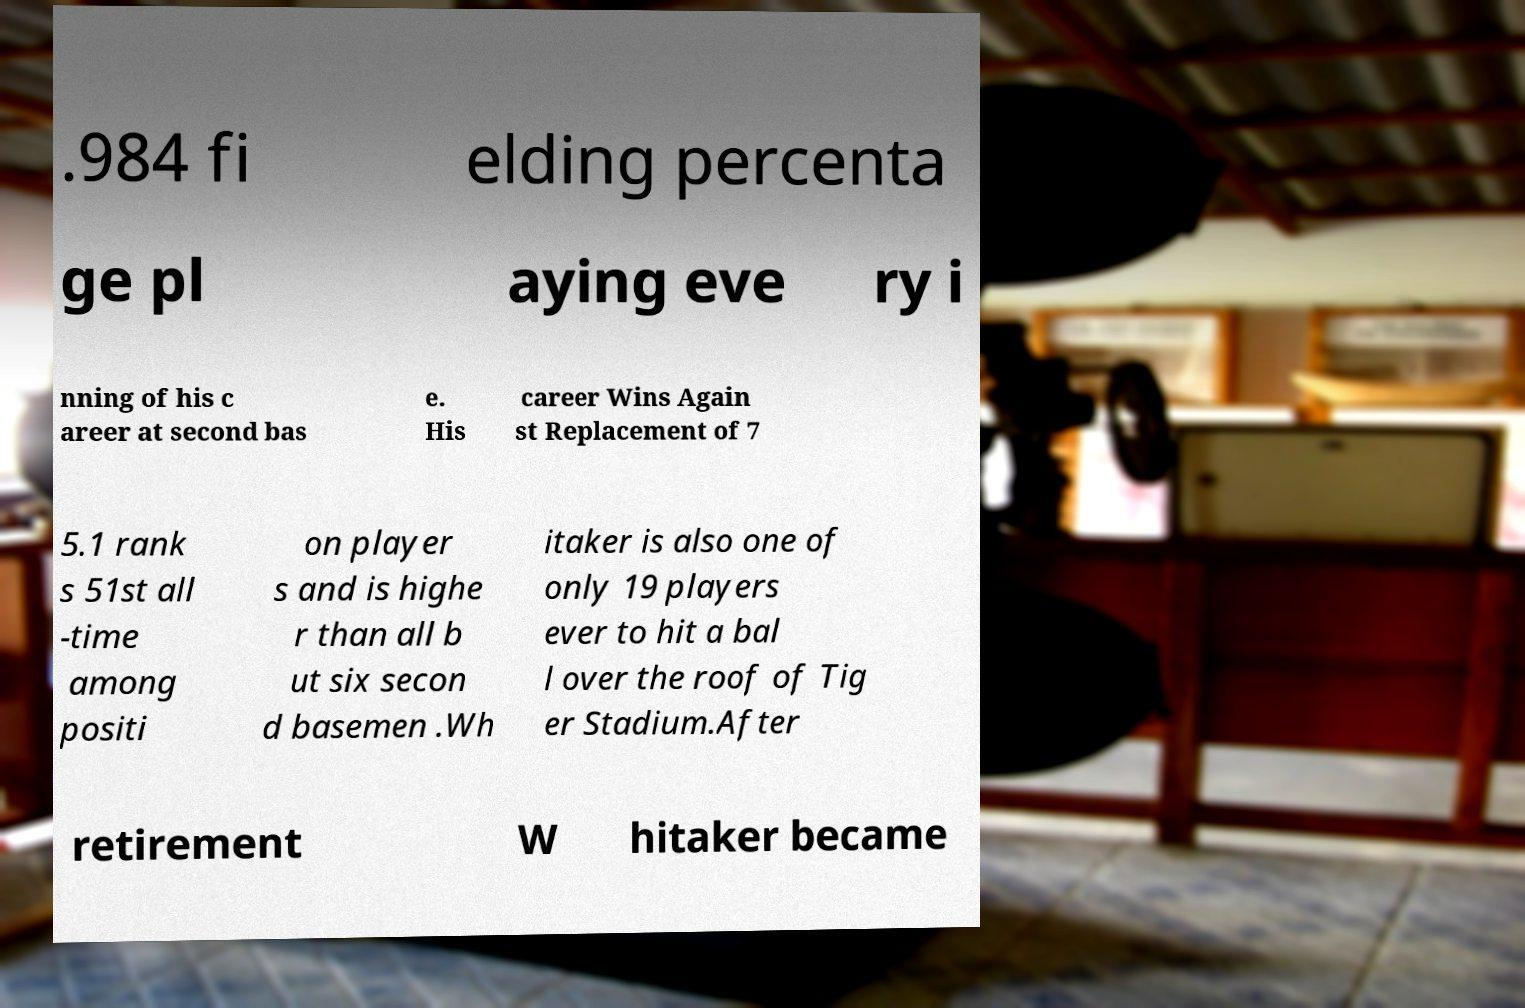Could you extract and type out the text from this image? .984 fi elding percenta ge pl aying eve ry i nning of his c areer at second bas e. His career Wins Again st Replacement of 7 5.1 rank s 51st all -time among positi on player s and is highe r than all b ut six secon d basemen .Wh itaker is also one of only 19 players ever to hit a bal l over the roof of Tig er Stadium.After retirement W hitaker became 